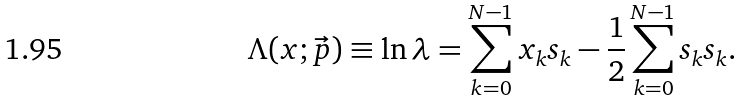Convert formula to latex. <formula><loc_0><loc_0><loc_500><loc_500>\Lambda ( x ; \vec { p } ) \equiv \ln \lambda = \sum _ { k = 0 } ^ { N - 1 } x _ { k } s _ { k } - \frac { 1 } { 2 } \sum _ { k = 0 } ^ { N - 1 } s _ { k } s _ { k } .</formula> 